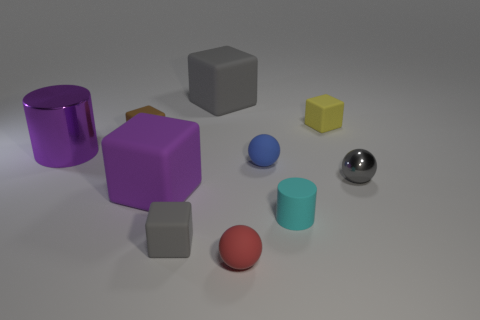If I were to combine the volumes of the two smallest spheres, would their combined volume be larger than the single blue cylinder in the image? By visually estimating, if you were to combine the volumes of the two smallest spheres, their combined volume would likely be similar to or slightly less than that of the blue cylinder, given their relative sizes in the image. 